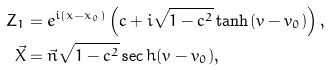<formula> <loc_0><loc_0><loc_500><loc_500>Z _ { 1 } & = e ^ { i ( x - x _ { 0 } ) } \left ( c + i \sqrt { 1 - c ^ { 2 } } \tanh ( v - v _ { 0 } ) \right ) , \\ \vec { X } & = \vec { n } \sqrt { 1 - c ^ { 2 } } \sec h ( v - v _ { 0 } ) ,</formula> 